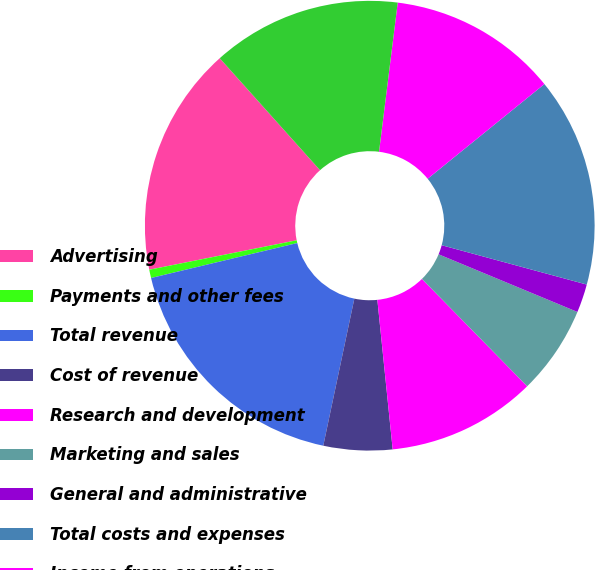Convert chart. <chart><loc_0><loc_0><loc_500><loc_500><pie_chart><fcel>Advertising<fcel>Payments and other fees<fcel>Total revenue<fcel>Cost of revenue<fcel>Research and development<fcel>Marketing and sales<fcel>General and administrative<fcel>Total costs and expenses<fcel>Income from operations<fcel>Income before provision for<nl><fcel>16.51%<fcel>0.6%<fcel>17.95%<fcel>4.94%<fcel>10.72%<fcel>6.39%<fcel>2.05%<fcel>15.06%<fcel>12.17%<fcel>13.61%<nl></chart> 